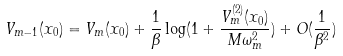<formula> <loc_0><loc_0><loc_500><loc_500>V _ { m - 1 } ( x _ { 0 } ) = V _ { m } ( x _ { 0 } ) + \frac { 1 } { \beta } \log ( 1 + \frac { V _ { m } ^ { ( 2 ) } ( x _ { 0 } ) } { M \omega _ { m } ^ { 2 } } ) + O ( \frac { 1 } { \beta ^ { 2 } } )</formula> 